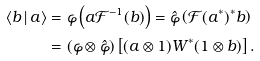<formula> <loc_0><loc_0><loc_500><loc_500>\langle b \, | \, a \rangle & = \varphi \left ( a { \mathcal { F } } ^ { - 1 } ( b ) \right ) = \hat { \varphi } \left ( { \mathcal { F } } ( a ^ { * } ) ^ { * } b \right ) \\ & = ( \varphi \otimes \hat { \varphi } ) \left [ ( a \otimes 1 ) W ^ { * } ( 1 \otimes b ) \right ] .</formula> 